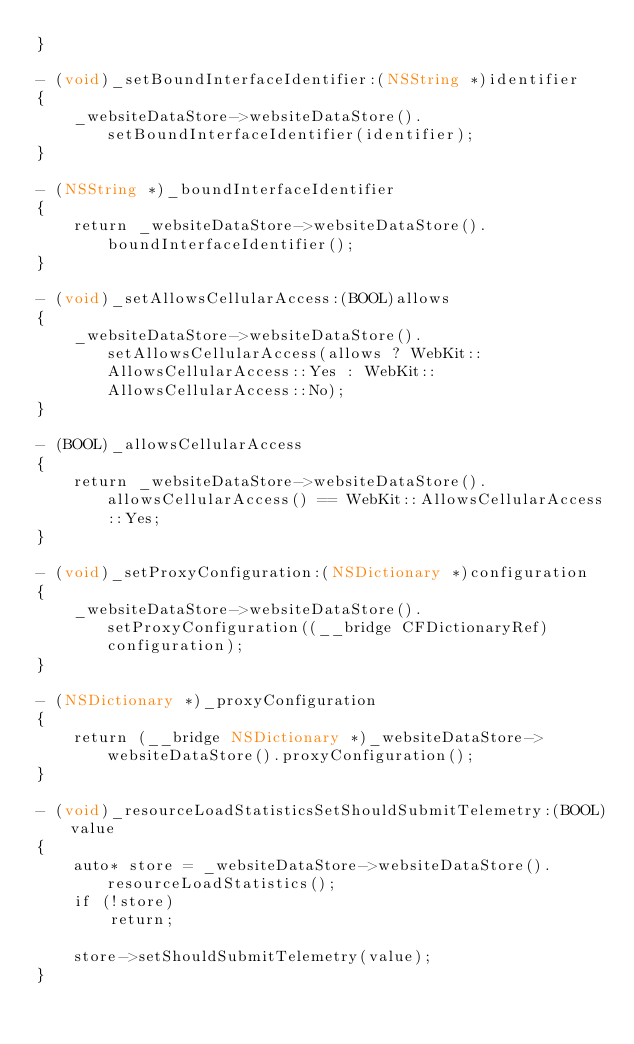Convert code to text. <code><loc_0><loc_0><loc_500><loc_500><_ObjectiveC_>}

- (void)_setBoundInterfaceIdentifier:(NSString *)identifier
{
    _websiteDataStore->websiteDataStore().setBoundInterfaceIdentifier(identifier);
}

- (NSString *)_boundInterfaceIdentifier
{
    return _websiteDataStore->websiteDataStore().boundInterfaceIdentifier();
}

- (void)_setAllowsCellularAccess:(BOOL)allows
{
    _websiteDataStore->websiteDataStore().setAllowsCellularAccess(allows ? WebKit::AllowsCellularAccess::Yes : WebKit::AllowsCellularAccess::No);
}

- (BOOL)_allowsCellularAccess
{
    return _websiteDataStore->websiteDataStore().allowsCellularAccess() == WebKit::AllowsCellularAccess::Yes;
}

- (void)_setProxyConfiguration:(NSDictionary *)configuration
{
    _websiteDataStore->websiteDataStore().setProxyConfiguration((__bridge CFDictionaryRef)configuration);
}

- (NSDictionary *)_proxyConfiguration
{
    return (__bridge NSDictionary *)_websiteDataStore->websiteDataStore().proxyConfiguration();
}

- (void)_resourceLoadStatisticsSetShouldSubmitTelemetry:(BOOL)value
{
    auto* store = _websiteDataStore->websiteDataStore().resourceLoadStatistics();
    if (!store)
        return;

    store->setShouldSubmitTelemetry(value);
}
</code> 